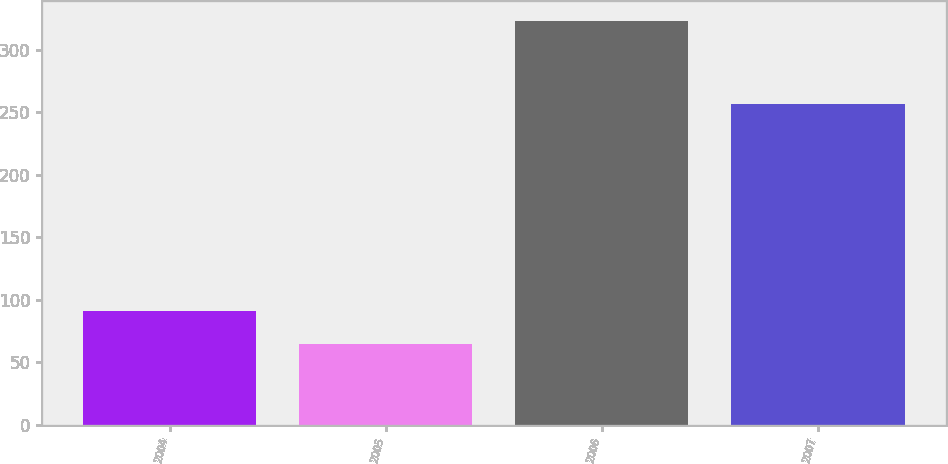Convert chart. <chart><loc_0><loc_0><loc_500><loc_500><bar_chart><fcel>2004<fcel>2005<fcel>2006<fcel>2007<nl><fcel>90.8<fcel>65<fcel>323<fcel>257<nl></chart> 